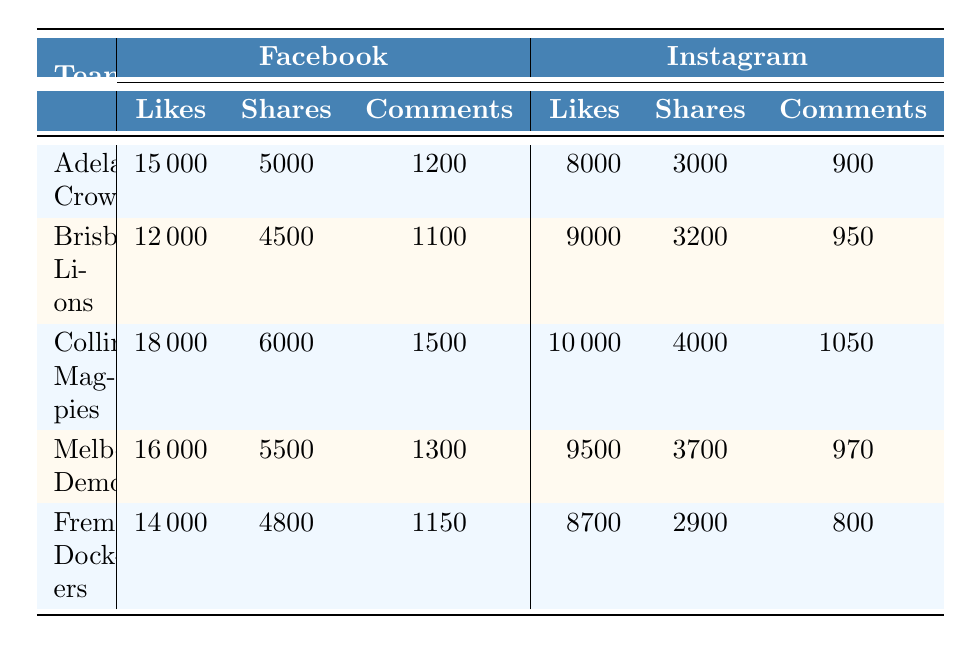What team has the highest number of likes on Facebook? The table shows likes for each team on Facebook, and by comparing the "Likes" column under Facebook, Collingwood Magpies has 18000 likes, which is the highest among all teams.
Answer: Collingwood Magpies What is the total number of likes for the Brisbane Lions on both platforms? For Brisbane Lions, 12000 likes are on Facebook and 9000 likes on Instagram. Adding them gives 12000 + 9000 = 21000 likes total.
Answer: 21000 Did any team receive more shares on Instagram than on Facebook? Comparing the shares for each team, Fremantle Dockers received 2900 shares on Instagram, while their Facebook shares are 4800. Thus, no team has more shares on Instagram than on Facebook.
Answer: No Which team had the least number of comments on Facebook? Looking at the "Comments" column under Facebook, Brisbane Lions have 1100 comments which is the least compared to other teams.
Answer: Brisbane Lions What is the average number of likes on Instagram across all teams? To find the average, sum the likes on Instagram: 8000 + 9000 + 10000 + 9500 + 8700 = 48500. Then divide by the number of teams, which is 5. Therefore, the average is 48500 / 5 = 9700.
Answer: 9700 Which team has the lowest total engagement (sum of likes, shares, and comments) on Facebook? Calculate the total engagement for each team on Facebook. For Adelaide Crows, it is 15000 + 5000 + 1200 = 21200; Brisbane Lions = 12000 + 4500 + 1100 = 17600; Collingwood Magpies = 18000 + 6000 + 1500 = 25500; Melbourne Demons = 16000 + 5500 + 1300 = 22800; Fremantle Dockers = 14000 + 4800 + 1150 = 20000. The lowest total is for Brisbane Lions at 17600.
Answer: Brisbane Lions Do any teams have the same number of shares on both platforms? By examining the shares column, the highest number on Facebook is 6000 for Collingwood, while the highest on Instagram is 4000. No team has the same number of shares on both platforms as each value differs.
Answer: No What is the difference in likes between the team with the most likes on Facebook and the team with the least likes on Facebook? The highest likes on Facebook is for Collingwood Magpies with 18000 likes and the lowest is for Brisbane Lions with 12000 likes. The difference is 18000 - 12000 = 6000.
Answer: 6000 Which platform has more comments overall? Sum the comments for each platform: Facebook = (1200 + 1100 + 1500 + 1300 + 1150) = 10250; Instagram = (900 + 950 + 1050 + 970 + 800) = 4670. Since 10250 > 4670, Facebook has more comments overall.
Answer: Facebook 